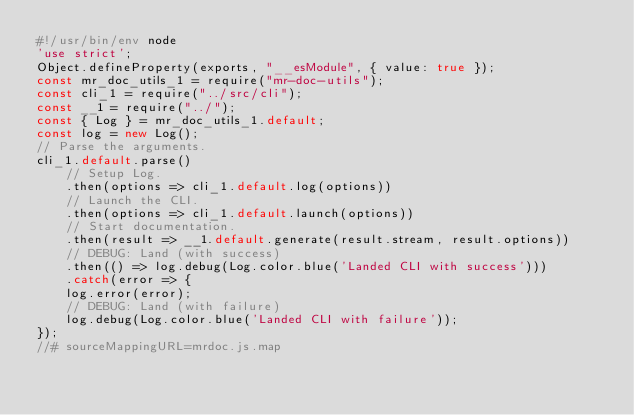<code> <loc_0><loc_0><loc_500><loc_500><_JavaScript_>#!/usr/bin/env node
'use strict';
Object.defineProperty(exports, "__esModule", { value: true });
const mr_doc_utils_1 = require("mr-doc-utils");
const cli_1 = require("../src/cli");
const __1 = require("../");
const { Log } = mr_doc_utils_1.default;
const log = new Log();
// Parse the arguments.
cli_1.default.parse()
    // Setup Log.
    .then(options => cli_1.default.log(options))
    // Launch the CLI.
    .then(options => cli_1.default.launch(options))
    // Start documentation.
    .then(result => __1.default.generate(result.stream, result.options))
    // DEBUG: Land (with success)
    .then(() => log.debug(Log.color.blue('Landed CLI with success')))
    .catch(error => {
    log.error(error);
    // DEBUG: Land (with failure)
    log.debug(Log.color.blue('Landed CLI with failure'));
});
//# sourceMappingURL=mrdoc.js.map</code> 